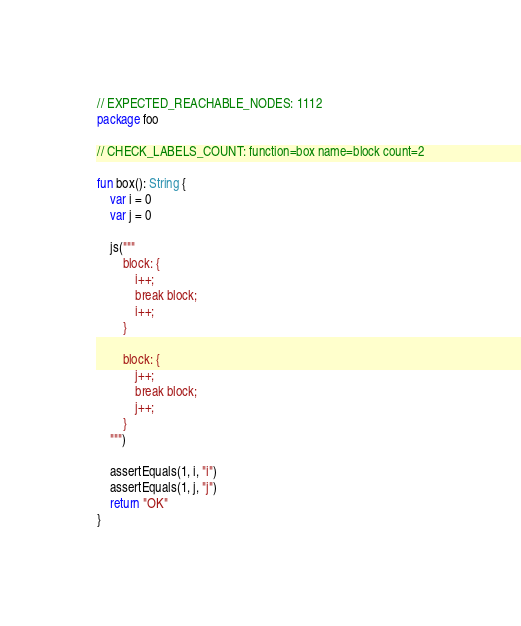<code> <loc_0><loc_0><loc_500><loc_500><_Kotlin_>// EXPECTED_REACHABLE_NODES: 1112
package foo

// CHECK_LABELS_COUNT: function=box name=block count=2

fun box(): String {
    var i = 0
    var j = 0

    js("""
        block: {
            i++;
            break block;
            i++;
        }

        block: {
            j++;
            break block;
            j++;
        }
    """)

    assertEquals(1, i, "i")
    assertEquals(1, j, "j")
    return "OK"
}</code> 